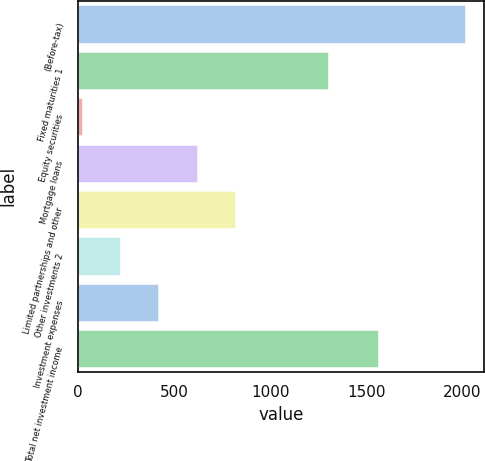Convert chart. <chart><loc_0><loc_0><loc_500><loc_500><bar_chart><fcel>(Before-tax)<fcel>Fixed maturities 1<fcel>Equity securities<fcel>Mortgage loans<fcel>Limited partnerships and other<fcel>Other investments 2<fcel>Investment expenses<fcel>Total net investment income<nl><fcel>2015<fcel>1301<fcel>17<fcel>616.4<fcel>816.2<fcel>216.8<fcel>416.6<fcel>1561<nl></chart> 